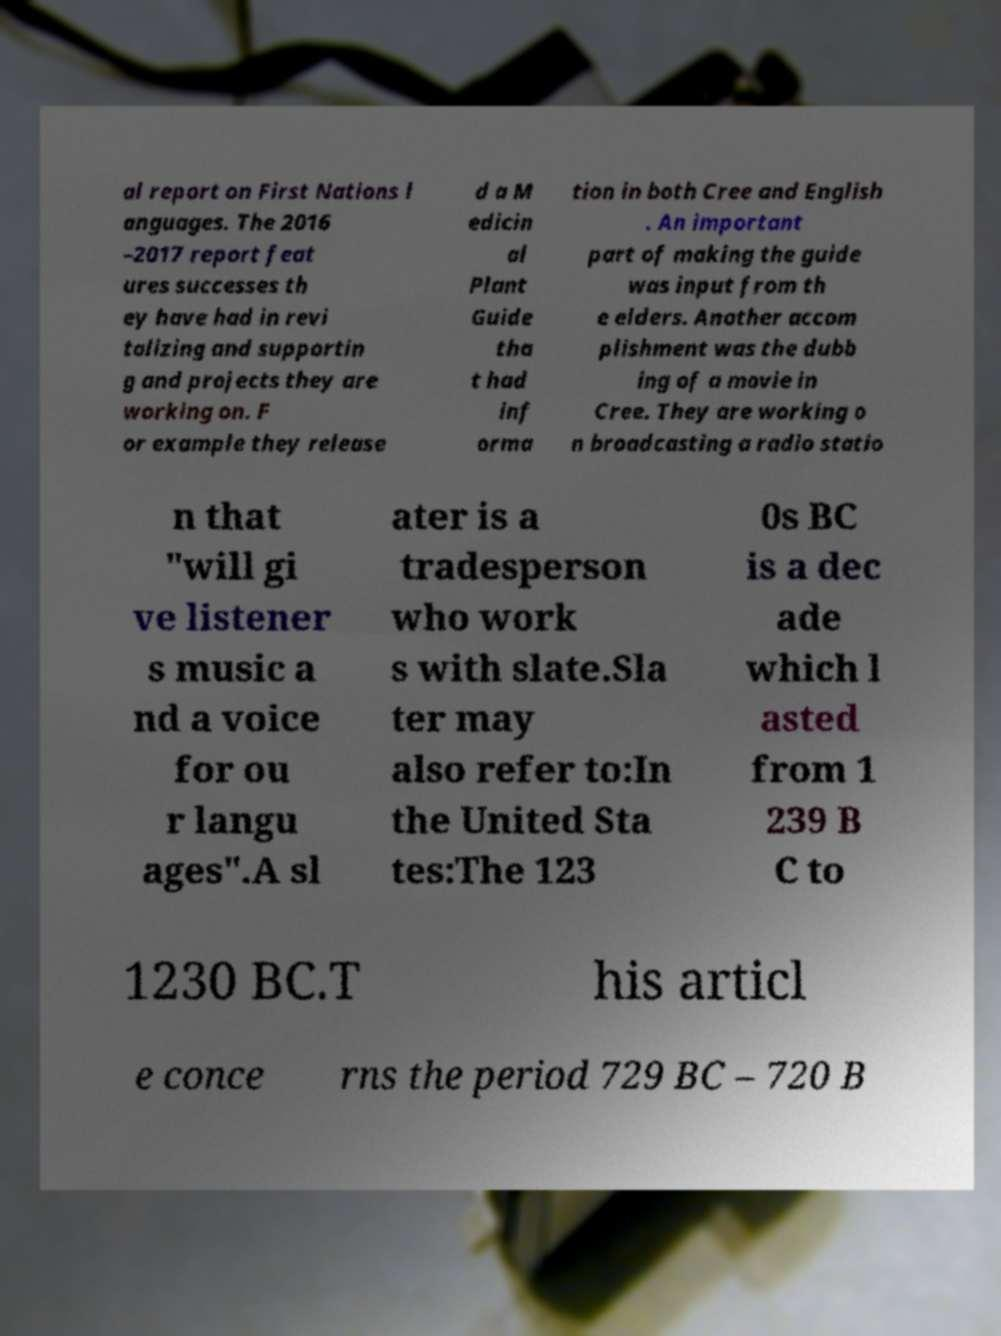There's text embedded in this image that I need extracted. Can you transcribe it verbatim? al report on First Nations l anguages. The 2016 –2017 report feat ures successes th ey have had in revi talizing and supportin g and projects they are working on. F or example they release d a M edicin al Plant Guide tha t had inf orma tion in both Cree and English . An important part of making the guide was input from th e elders. Another accom plishment was the dubb ing of a movie in Cree. They are working o n broadcasting a radio statio n that "will gi ve listener s music a nd a voice for ou r langu ages".A sl ater is a tradesperson who work s with slate.Sla ter may also refer to:In the United Sta tes:The 123 0s BC is a dec ade which l asted from 1 239 B C to 1230 BC.T his articl e conce rns the period 729 BC – 720 B 